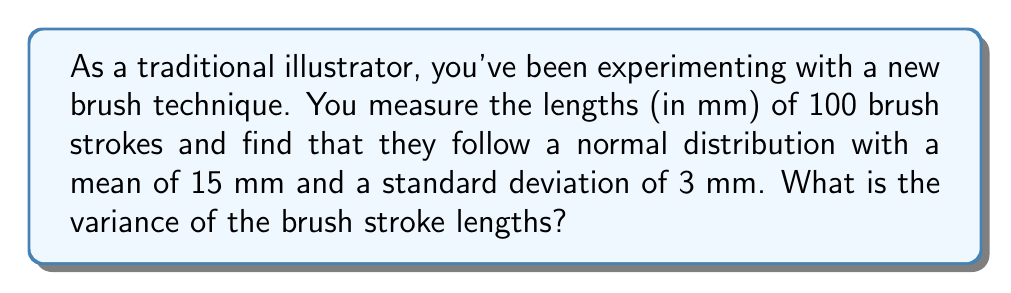Could you help me with this problem? Let's approach this step-by-step:

1) We are given that the brush stroke lengths follow a normal distribution with:
   - Mean (μ) = 15 mm
   - Standard deviation (σ) = 3 mm

2) The variance (σ²) is defined as the square of the standard deviation.

3) Therefore, we can calculate the variance using the formula:
   
   $$σ² = σ^2$$

4) Substituting the given standard deviation:

   $$σ² = (3 \text{ mm})^2$$

5) Calculate:

   $$σ² = 9 \text{ mm}^2$$

Thus, the variance of the brush stroke lengths is 9 square millimeters.
Answer: $9 \text{ mm}^2$ 